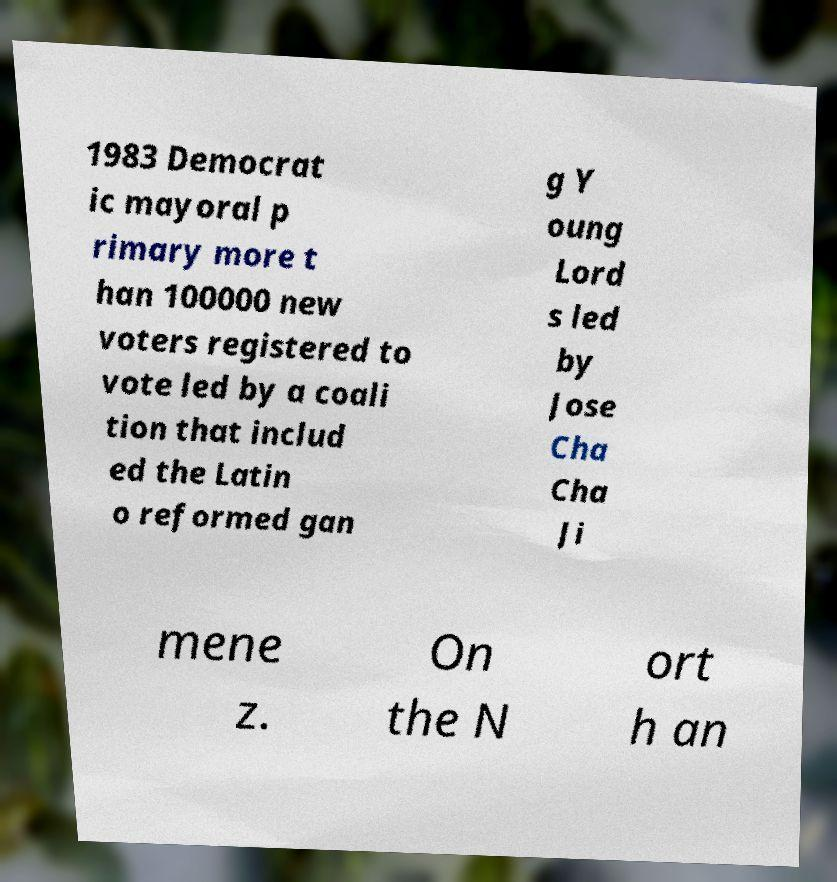Please read and relay the text visible in this image. What does it say? 1983 Democrat ic mayoral p rimary more t han 100000 new voters registered to vote led by a coali tion that includ ed the Latin o reformed gan g Y oung Lord s led by Jose Cha Cha Ji mene z. On the N ort h an 